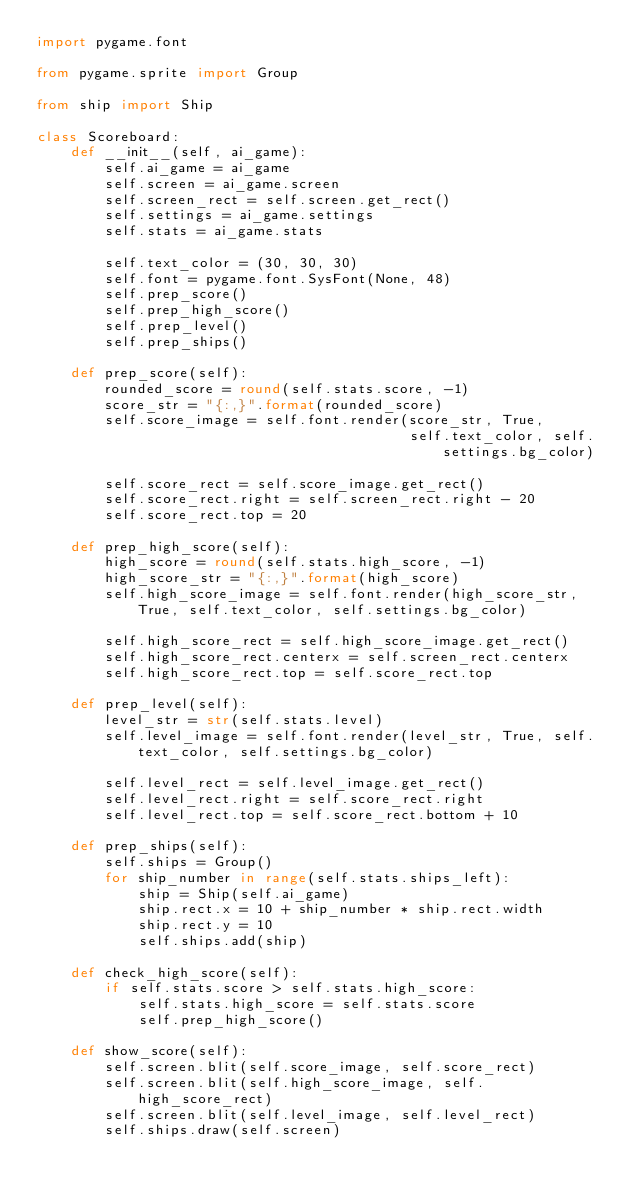<code> <loc_0><loc_0><loc_500><loc_500><_Python_>import pygame.font

from pygame.sprite import Group

from ship import Ship

class Scoreboard:
    def __init__(self, ai_game):
        self.ai_game = ai_game
        self.screen = ai_game.screen
        self.screen_rect = self.screen.get_rect()
        self.settings = ai_game.settings
        self.stats = ai_game.stats

        self.text_color = (30, 30, 30)
        self.font = pygame.font.SysFont(None, 48)
        self.prep_score()
        self.prep_high_score()
        self.prep_level()
        self.prep_ships()

    def prep_score(self):
        rounded_score = round(self.stats.score, -1)
        score_str = "{:,}".format(rounded_score)
        self.score_image = self.font.render(score_str, True,
                                            self.text_color, self.settings.bg_color)

        self.score_rect = self.score_image.get_rect()
        self.score_rect.right = self.screen_rect.right - 20
        self.score_rect.top = 20

    def prep_high_score(self):
        high_score = round(self.stats.high_score, -1)
        high_score_str = "{:,}".format(high_score)
        self.high_score_image = self.font.render(high_score_str, True, self.text_color, self.settings.bg_color)

        self.high_score_rect = self.high_score_image.get_rect()
        self.high_score_rect.centerx = self.screen_rect.centerx
        self.high_score_rect.top = self.score_rect.top

    def prep_level(self):
        level_str = str(self.stats.level)
        self.level_image = self.font.render(level_str, True, self.text_color, self.settings.bg_color)

        self.level_rect = self.level_image.get_rect()
        self.level_rect.right = self.score_rect.right
        self.level_rect.top = self.score_rect.bottom + 10

    def prep_ships(self):
        self.ships = Group()
        for ship_number in range(self.stats.ships_left):
            ship = Ship(self.ai_game)
            ship.rect.x = 10 + ship_number * ship.rect.width
            ship.rect.y = 10
            self.ships.add(ship)

    def check_high_score(self):
        if self.stats.score > self.stats.high_score:
            self.stats.high_score = self.stats.score
            self.prep_high_score()

    def show_score(self):
        self.screen.blit(self.score_image, self.score_rect)
        self.screen.blit(self.high_score_image, self.high_score_rect)
        self.screen.blit(self.level_image, self.level_rect)
        self.ships.draw(self.screen)

</code> 